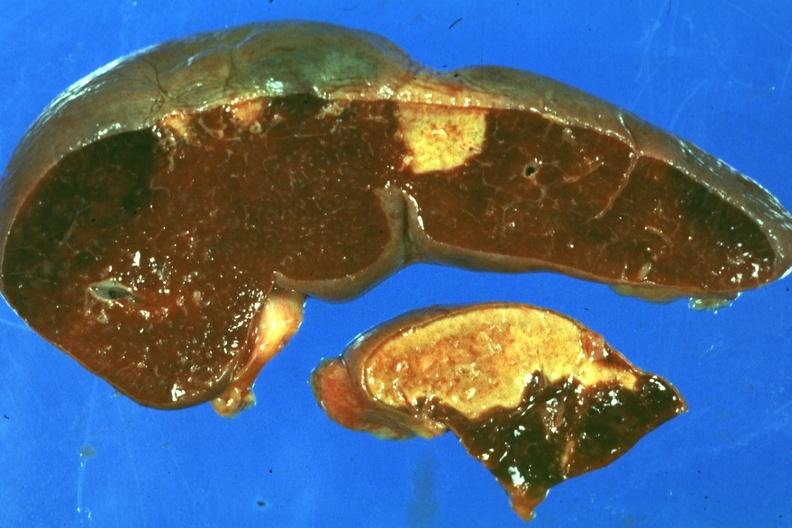s chronic myelogenous leukemia in blast crisis present?
Answer the question using a single word or phrase. No 